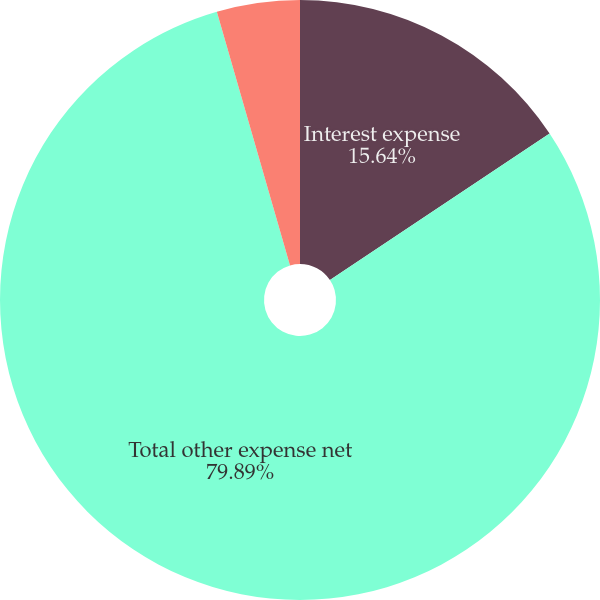<chart> <loc_0><loc_0><loc_500><loc_500><pie_chart><fcel>Interest expense<fcel>Total other expense net<fcel>Net income attributable to<nl><fcel>15.64%<fcel>79.89%<fcel>4.47%<nl></chart> 